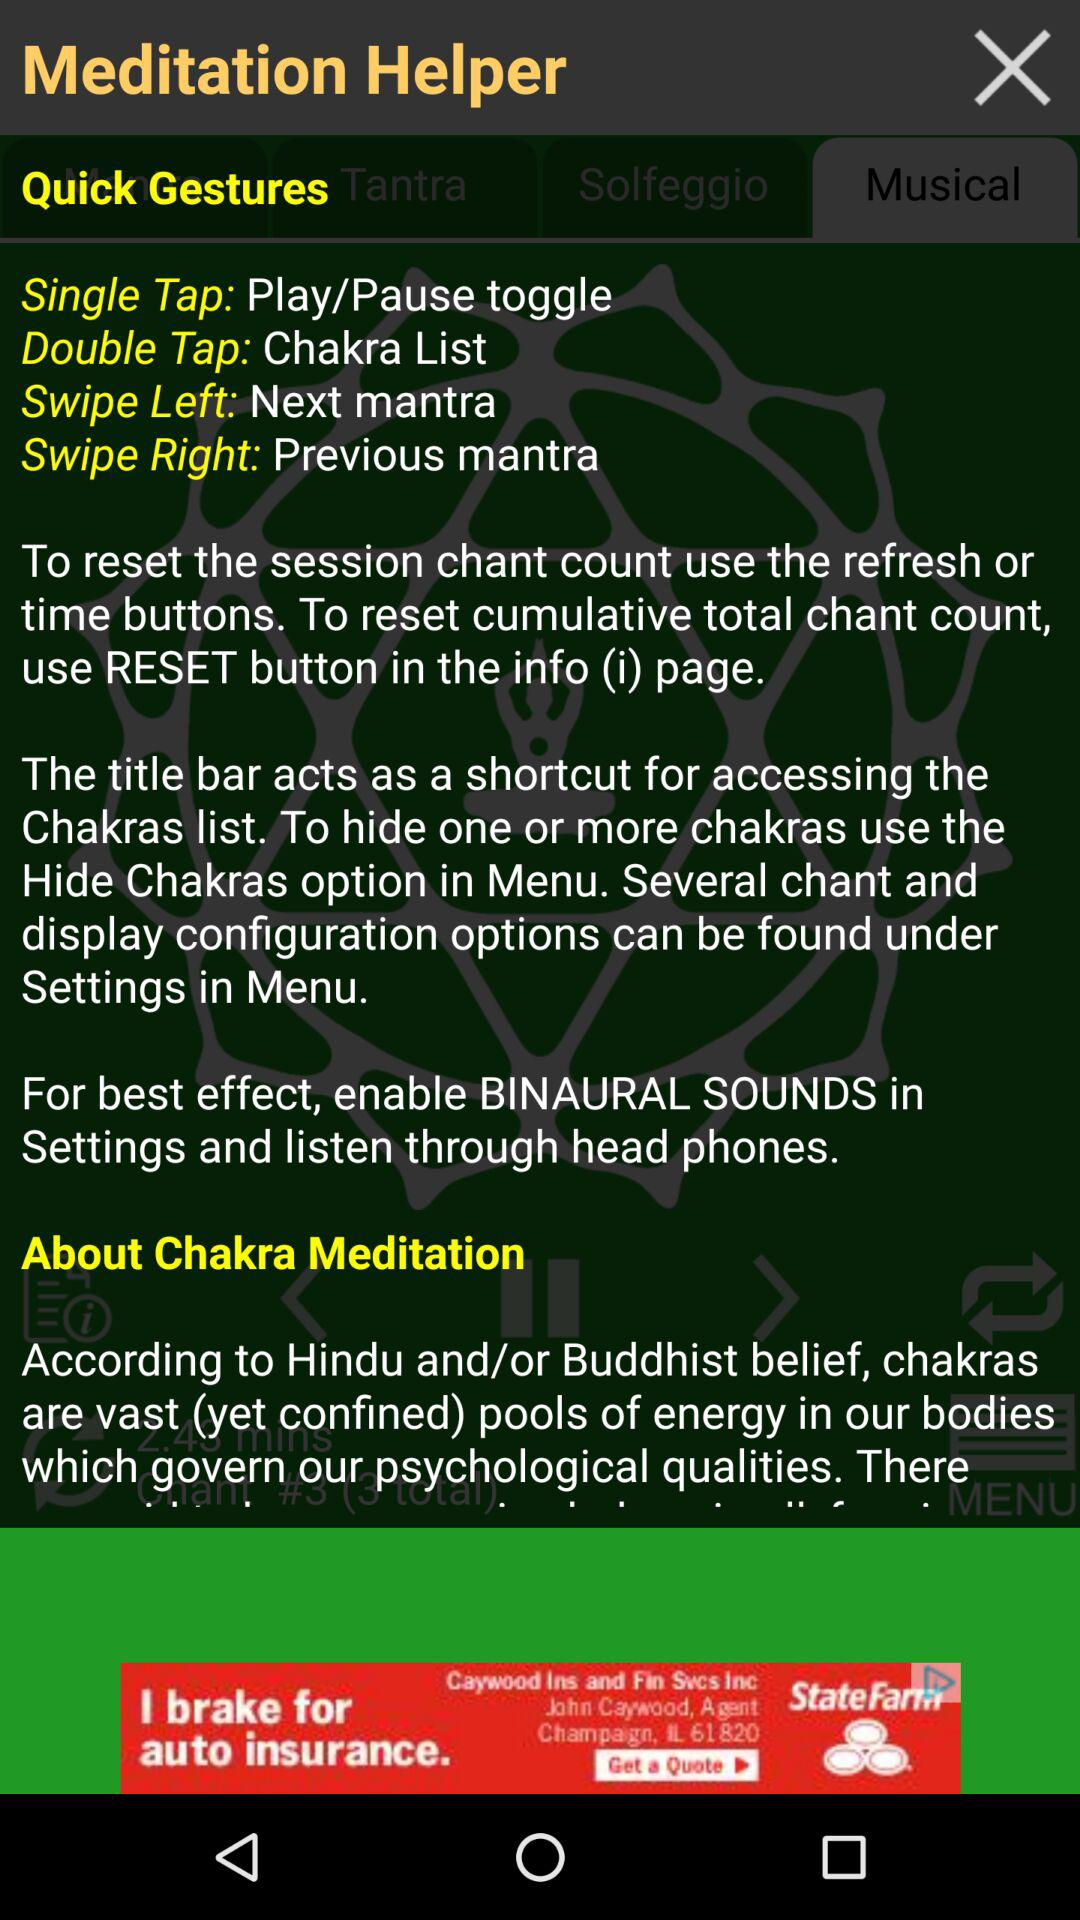What is the gesture for "Play/Pause toggle"? The gesture for "Play/Pause toggle" is a single tap. 